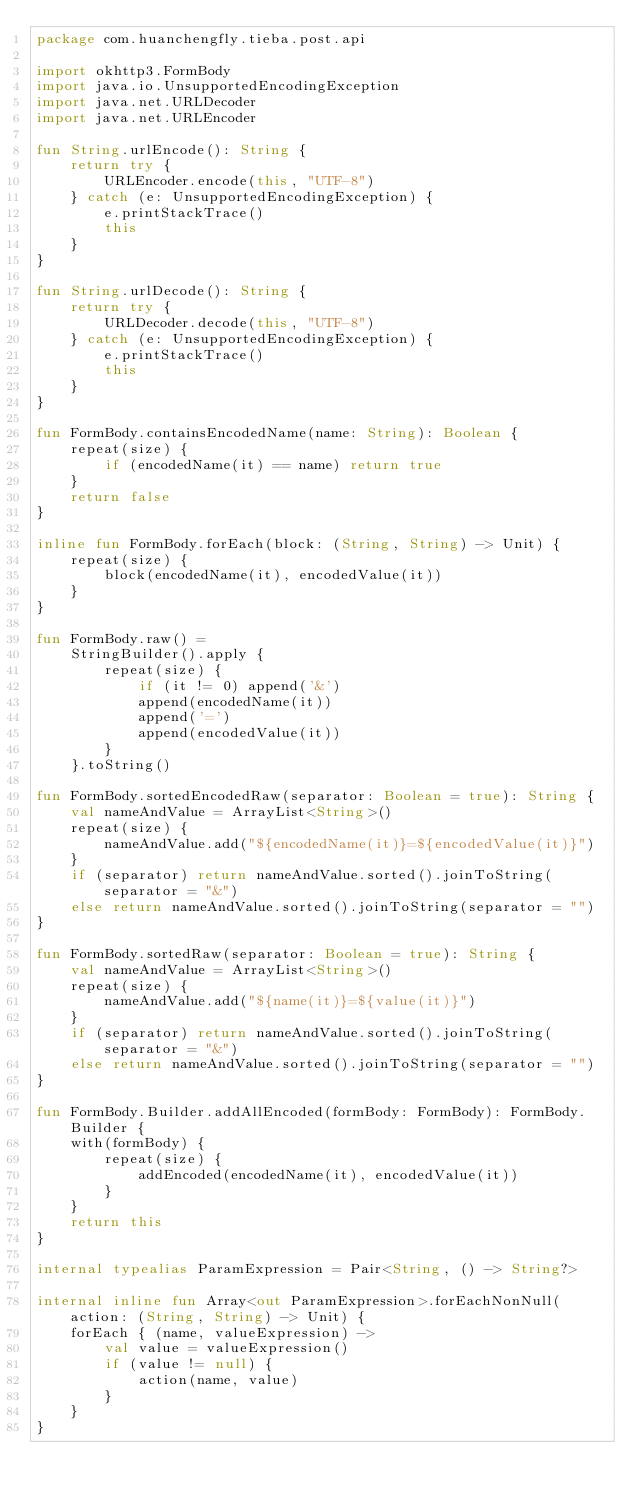Convert code to text. <code><loc_0><loc_0><loc_500><loc_500><_Kotlin_>package com.huanchengfly.tieba.post.api

import okhttp3.FormBody
import java.io.UnsupportedEncodingException
import java.net.URLDecoder
import java.net.URLEncoder

fun String.urlEncode(): String {
    return try {
        URLEncoder.encode(this, "UTF-8")
    } catch (e: UnsupportedEncodingException) {
        e.printStackTrace()
        this
    }
}

fun String.urlDecode(): String {
    return try {
        URLDecoder.decode(this, "UTF-8")
    } catch (e: UnsupportedEncodingException) {
        e.printStackTrace()
        this
    }
}

fun FormBody.containsEncodedName(name: String): Boolean {
    repeat(size) {
        if (encodedName(it) == name) return true
    }
    return false
}

inline fun FormBody.forEach(block: (String, String) -> Unit) {
    repeat(size) {
        block(encodedName(it), encodedValue(it))
    }
}

fun FormBody.raw() =
    StringBuilder().apply {
        repeat(size) {
            if (it != 0) append('&')
            append(encodedName(it))
            append('=')
            append(encodedValue(it))
        }
    }.toString()

fun FormBody.sortedEncodedRaw(separator: Boolean = true): String {
    val nameAndValue = ArrayList<String>()
    repeat(size) {
        nameAndValue.add("${encodedName(it)}=${encodedValue(it)}")
    }
    if (separator) return nameAndValue.sorted().joinToString(separator = "&")
    else return nameAndValue.sorted().joinToString(separator = "")
}

fun FormBody.sortedRaw(separator: Boolean = true): String {
    val nameAndValue = ArrayList<String>()
    repeat(size) {
        nameAndValue.add("${name(it)}=${value(it)}")
    }
    if (separator) return nameAndValue.sorted().joinToString(separator = "&")
    else return nameAndValue.sorted().joinToString(separator = "")
}

fun FormBody.Builder.addAllEncoded(formBody: FormBody): FormBody.Builder {
    with(formBody) {
        repeat(size) {
            addEncoded(encodedName(it), encodedValue(it))
        }
    }
    return this
}

internal typealias ParamExpression = Pair<String, () -> String?>

internal inline fun Array<out ParamExpression>.forEachNonNull(action: (String, String) -> Unit) {
    forEach { (name, valueExpression) ->
        val value = valueExpression()
        if (value != null) {
            action(name, value)
        }
    }
}</code> 